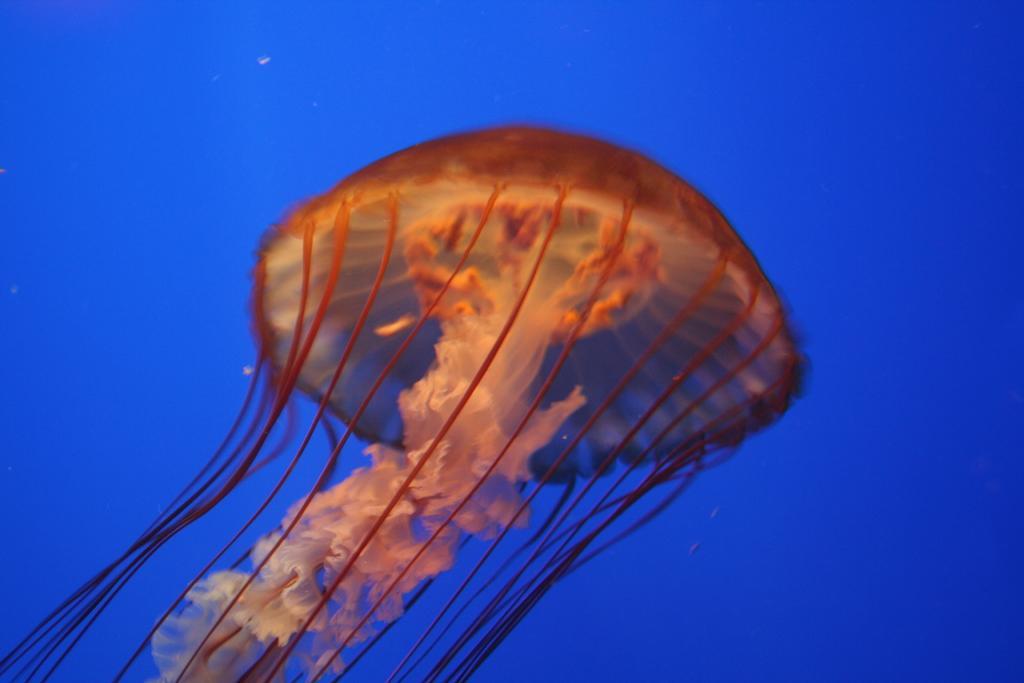In one or two sentences, can you explain what this image depicts? In this image I can see a jellyfish inside the water. The background is in blue color. 